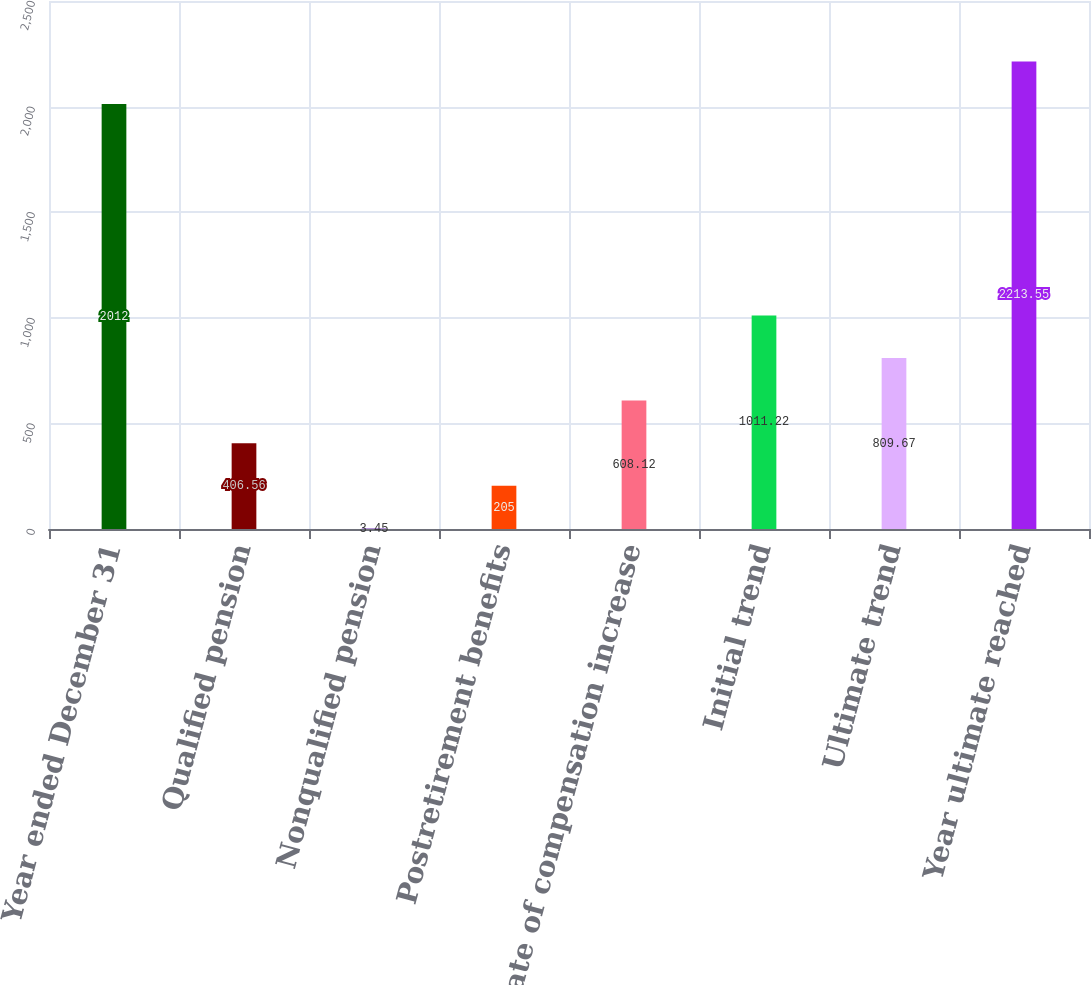<chart> <loc_0><loc_0><loc_500><loc_500><bar_chart><fcel>Year ended December 31<fcel>Qualified pension<fcel>Nonqualified pension<fcel>Postretirement benefits<fcel>Rate of compensation increase<fcel>Initial trend<fcel>Ultimate trend<fcel>Year ultimate reached<nl><fcel>2012<fcel>406.56<fcel>3.45<fcel>205<fcel>608.12<fcel>1011.22<fcel>809.67<fcel>2213.55<nl></chart> 